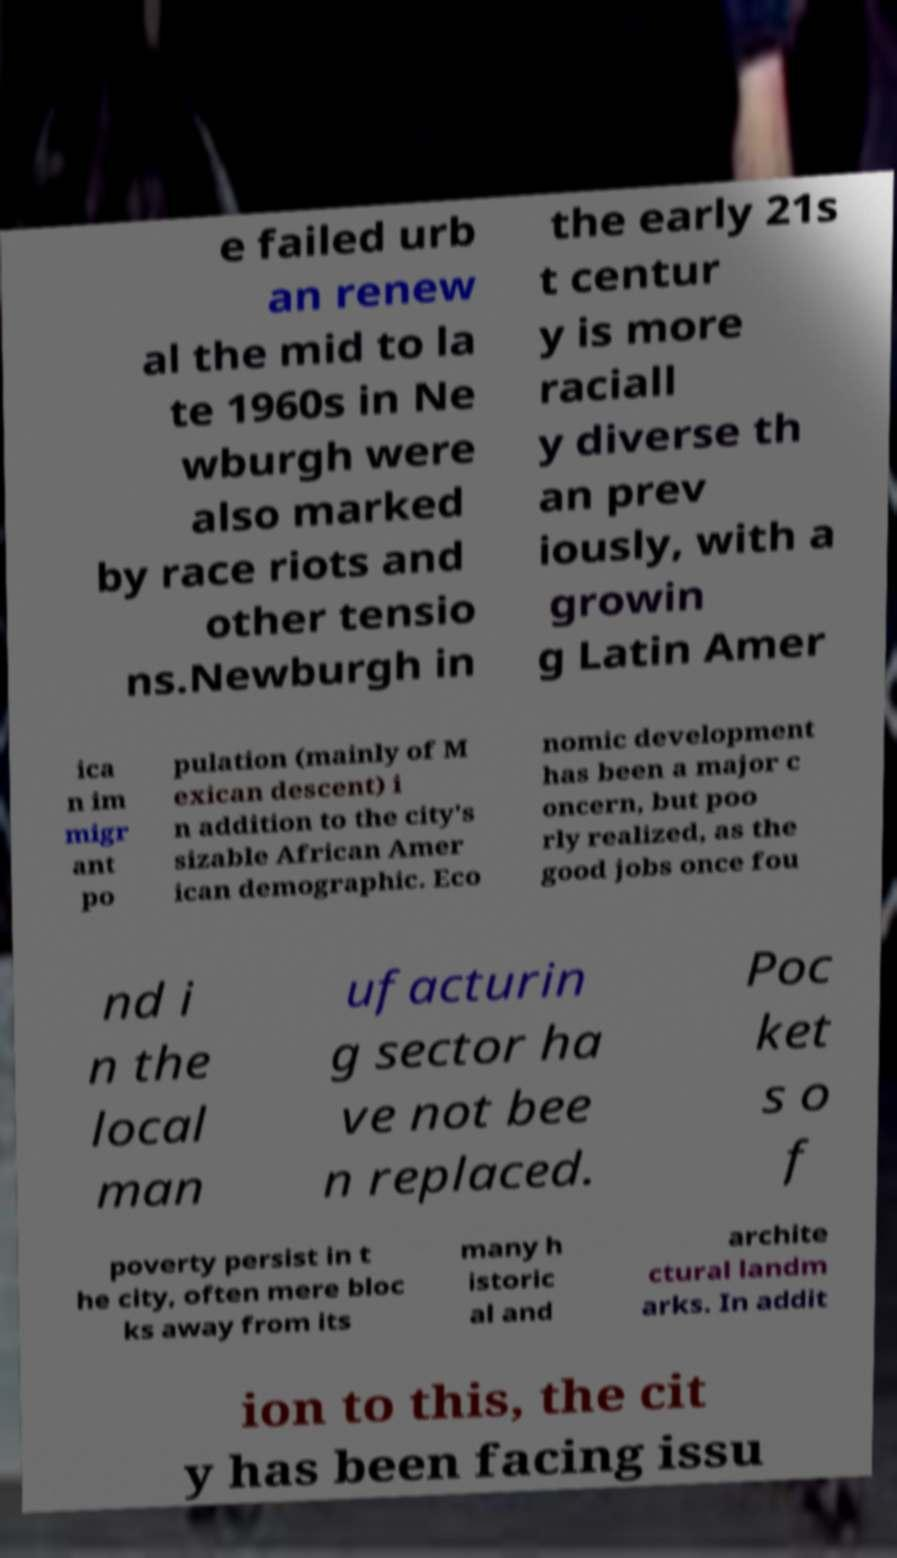What messages or text are displayed in this image? I need them in a readable, typed format. e failed urb an renew al the mid to la te 1960s in Ne wburgh were also marked by race riots and other tensio ns.Newburgh in the early 21s t centur y is more raciall y diverse th an prev iously, with a growin g Latin Amer ica n im migr ant po pulation (mainly of M exican descent) i n addition to the city's sizable African Amer ican demographic. Eco nomic development has been a major c oncern, but poo rly realized, as the good jobs once fou nd i n the local man ufacturin g sector ha ve not bee n replaced. Poc ket s o f poverty persist in t he city, often mere bloc ks away from its many h istoric al and archite ctural landm arks. In addit ion to this, the cit y has been facing issu 